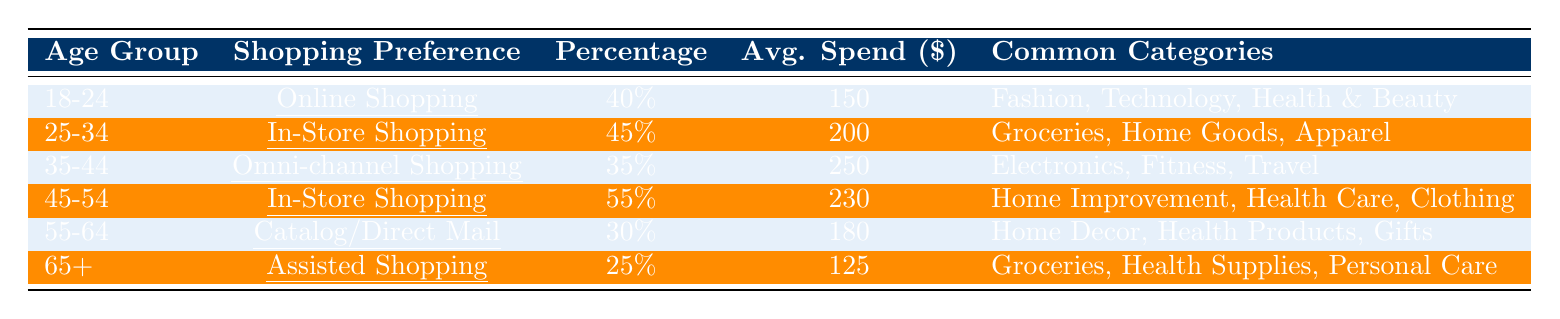What percentage of the 45-54 age group prefers In-Store Shopping? The table shows that for the 45-54 age group, the shopping preference is In-Store Shopping with a percentage of 55%.
Answer: 55% Which age group has the highest average spend? By examining the average spend column, the age group 35-44 has the highest average spend of $250.
Answer: 35-44 What is the average percentage of those who prefer Online Shopping and Catalog/Direct Mail? The age groups that prefer Online Shopping and Catalog/Direct Mail are 18-24 (40%) and 55-64 (30%), respectively. The average percentage is (40% + 30%) / 2 = 35%.
Answer: 35% Is the shopping preference for the 65+ age group more towards Assisted Shopping? The table indicates that for the 65+ age group, the shopping preference listed is Assisted Shopping, thus confirming it is more towards this type.
Answer: Yes How much more does the 35-44 age group spend on average compared to the 18-24 group? The average spend for the 35-44 age group is $250, while for the 18-24 group, it is $150. The difference is $250 - $150 = $100.
Answer: $100 Which shopping preference is favored by the majority of the 25-34 age group, and how does it compare to the 55-64 age group? The 25-34 age group favors In-Store Shopping at 45%, while the 55-64 age group opts for Catalog/Direct Mail at 30%. The majority preference for 25-34 is higher by 15%.
Answer: 15% What are the common categories for the 55-64 age group's shopping preferences? Looking at the last data entry for the 55-64 age group, the common categories are Home Decor, Health Products, and Gifts.
Answer: Home Decor, Health Products, Gifts If we combine the percentage of the 18-24 and 55-64 age groups, what is their total percentage of shopping preferences? The percentages for the 18-24 group (40%) and the 55-64 group (30%) total to 40% + 30% = 70%.
Answer: 70% Which age group spends the least on average, and what is that amount? The age group that spends the least on average is 65+, with an average spend of $125.
Answer: $125 How many age groups have a shopping preference for In-Store Shopping? The table lists two age groups (25-34 and 45-54) with In-Store Shopping as their preference.
Answer: 2 